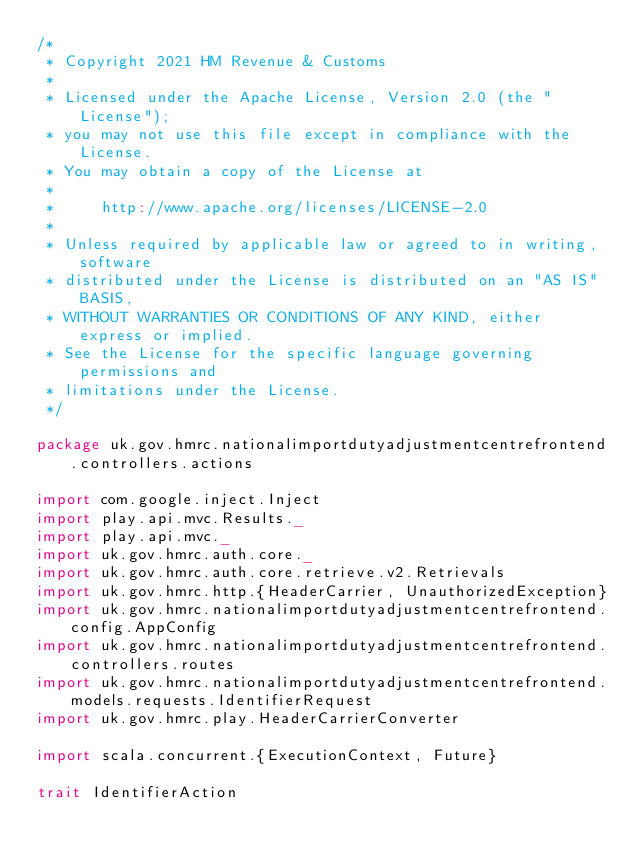Convert code to text. <code><loc_0><loc_0><loc_500><loc_500><_Scala_>/*
 * Copyright 2021 HM Revenue & Customs
 *
 * Licensed under the Apache License, Version 2.0 (the "License");
 * you may not use this file except in compliance with the License.
 * You may obtain a copy of the License at
 *
 *     http://www.apache.org/licenses/LICENSE-2.0
 *
 * Unless required by applicable law or agreed to in writing, software
 * distributed under the License is distributed on an "AS IS" BASIS,
 * WITHOUT WARRANTIES OR CONDITIONS OF ANY KIND, either express or implied.
 * See the License for the specific language governing permissions and
 * limitations under the License.
 */

package uk.gov.hmrc.nationalimportdutyadjustmentcentrefrontend.controllers.actions

import com.google.inject.Inject
import play.api.mvc.Results._
import play.api.mvc._
import uk.gov.hmrc.auth.core._
import uk.gov.hmrc.auth.core.retrieve.v2.Retrievals
import uk.gov.hmrc.http.{HeaderCarrier, UnauthorizedException}
import uk.gov.hmrc.nationalimportdutyadjustmentcentrefrontend.config.AppConfig
import uk.gov.hmrc.nationalimportdutyadjustmentcentrefrontend.controllers.routes
import uk.gov.hmrc.nationalimportdutyadjustmentcentrefrontend.models.requests.IdentifierRequest
import uk.gov.hmrc.play.HeaderCarrierConverter

import scala.concurrent.{ExecutionContext, Future}

trait IdentifierAction</code> 